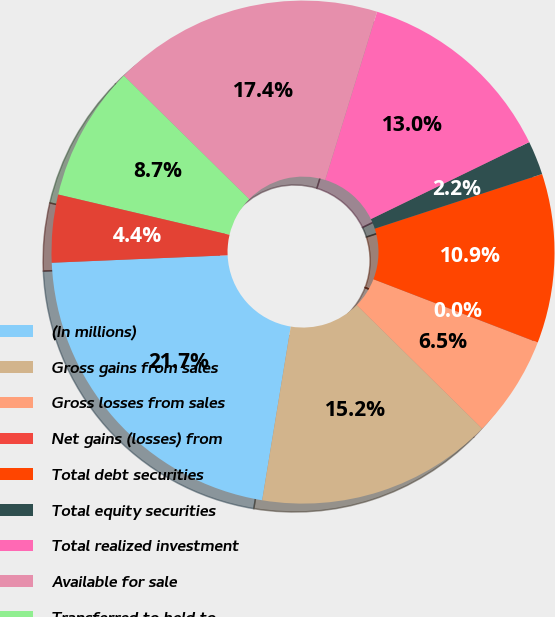Convert chart. <chart><loc_0><loc_0><loc_500><loc_500><pie_chart><fcel>(In millions)<fcel>Gross gains from sales<fcel>Gross losses from sales<fcel>Net gains (losses) from<fcel>Total debt securities<fcel>Total equity securities<fcel>Total realized investment<fcel>Available for sale<fcel>Transferred to held to<fcel>Equity securities<nl><fcel>21.73%<fcel>15.21%<fcel>6.53%<fcel>0.01%<fcel>10.87%<fcel>2.18%<fcel>13.04%<fcel>17.38%<fcel>8.7%<fcel>4.35%<nl></chart> 